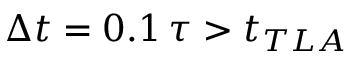Convert formula to latex. <formula><loc_0><loc_0><loc_500><loc_500>\Delta t = 0 . 1 \, \tau > t _ { T L A }</formula> 